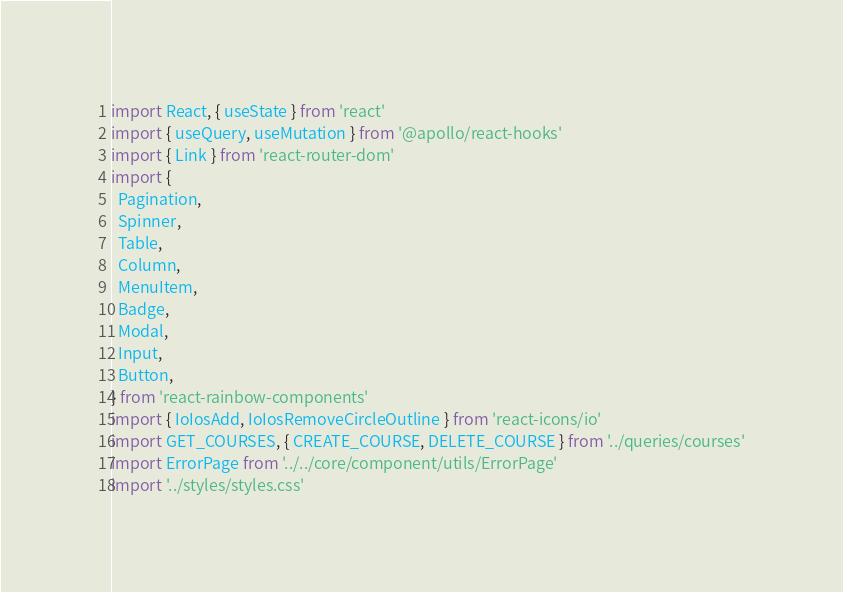<code> <loc_0><loc_0><loc_500><loc_500><_JavaScript_>import React, { useState } from 'react'
import { useQuery, useMutation } from '@apollo/react-hooks'
import { Link } from 'react-router-dom'
import {
  Pagination,
  Spinner,
  Table,
  Column,
  MenuItem,
  Badge,
  Modal,
  Input,
  Button,
} from 'react-rainbow-components'
import { IoIosAdd, IoIosRemoveCircleOutline } from 'react-icons/io'
import GET_COURSES, { CREATE_COURSE, DELETE_COURSE } from '../queries/courses'
import ErrorPage from '../../core/component/utils/ErrorPage'
import '../styles/styles.css'</code> 